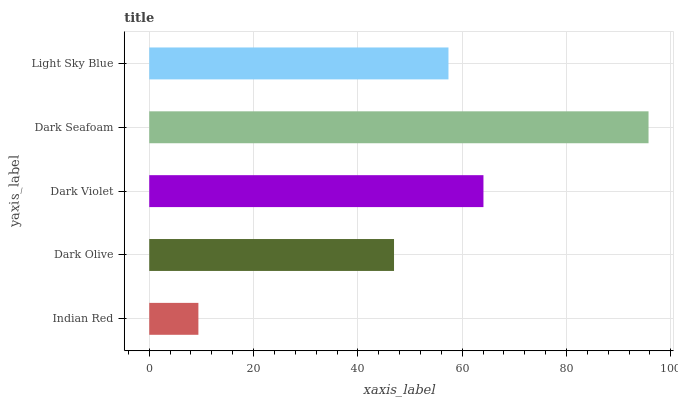Is Indian Red the minimum?
Answer yes or no. Yes. Is Dark Seafoam the maximum?
Answer yes or no. Yes. Is Dark Olive the minimum?
Answer yes or no. No. Is Dark Olive the maximum?
Answer yes or no. No. Is Dark Olive greater than Indian Red?
Answer yes or no. Yes. Is Indian Red less than Dark Olive?
Answer yes or no. Yes. Is Indian Red greater than Dark Olive?
Answer yes or no. No. Is Dark Olive less than Indian Red?
Answer yes or no. No. Is Light Sky Blue the high median?
Answer yes or no. Yes. Is Light Sky Blue the low median?
Answer yes or no. Yes. Is Dark Violet the high median?
Answer yes or no. No. Is Indian Red the low median?
Answer yes or no. No. 